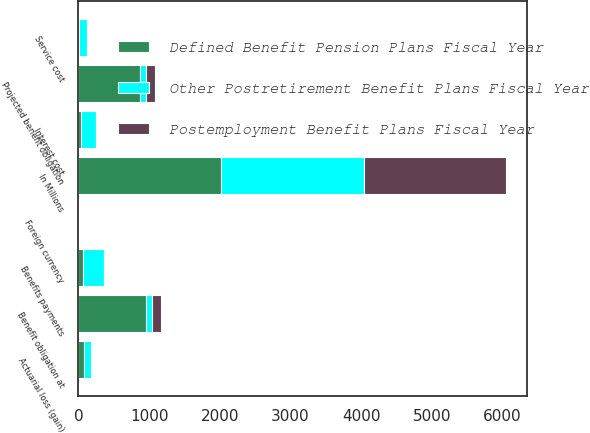<chart> <loc_0><loc_0><loc_500><loc_500><stacked_bar_chart><ecel><fcel>In Millions<fcel>Benefit obligation at<fcel>Service cost<fcel>Interest cost<fcel>Actuarial loss (gain)<fcel>Benefits payments<fcel>Foreign currency<fcel>Projected benefit obligation<nl><fcel>Other Postretirement Benefit Plans Fiscal Year<fcel>2018<fcel>87.95<fcel>102.9<fcel>217.9<fcel>102<fcel>298.6<fcel>5.7<fcel>87.95<nl><fcel>Defined Benefit Pension Plans Fiscal Year<fcel>2018<fcel>951.4<fcel>11.6<fcel>30.1<fcel>73.9<fcel>64.9<fcel>0.5<fcel>871.8<nl><fcel>Postemployment Benefit Plans Fiscal Year<fcel>2018<fcel>134.5<fcel>8.6<fcel>2.3<fcel>7<fcel>13.1<fcel>0.2<fcel>126.7<nl></chart> 